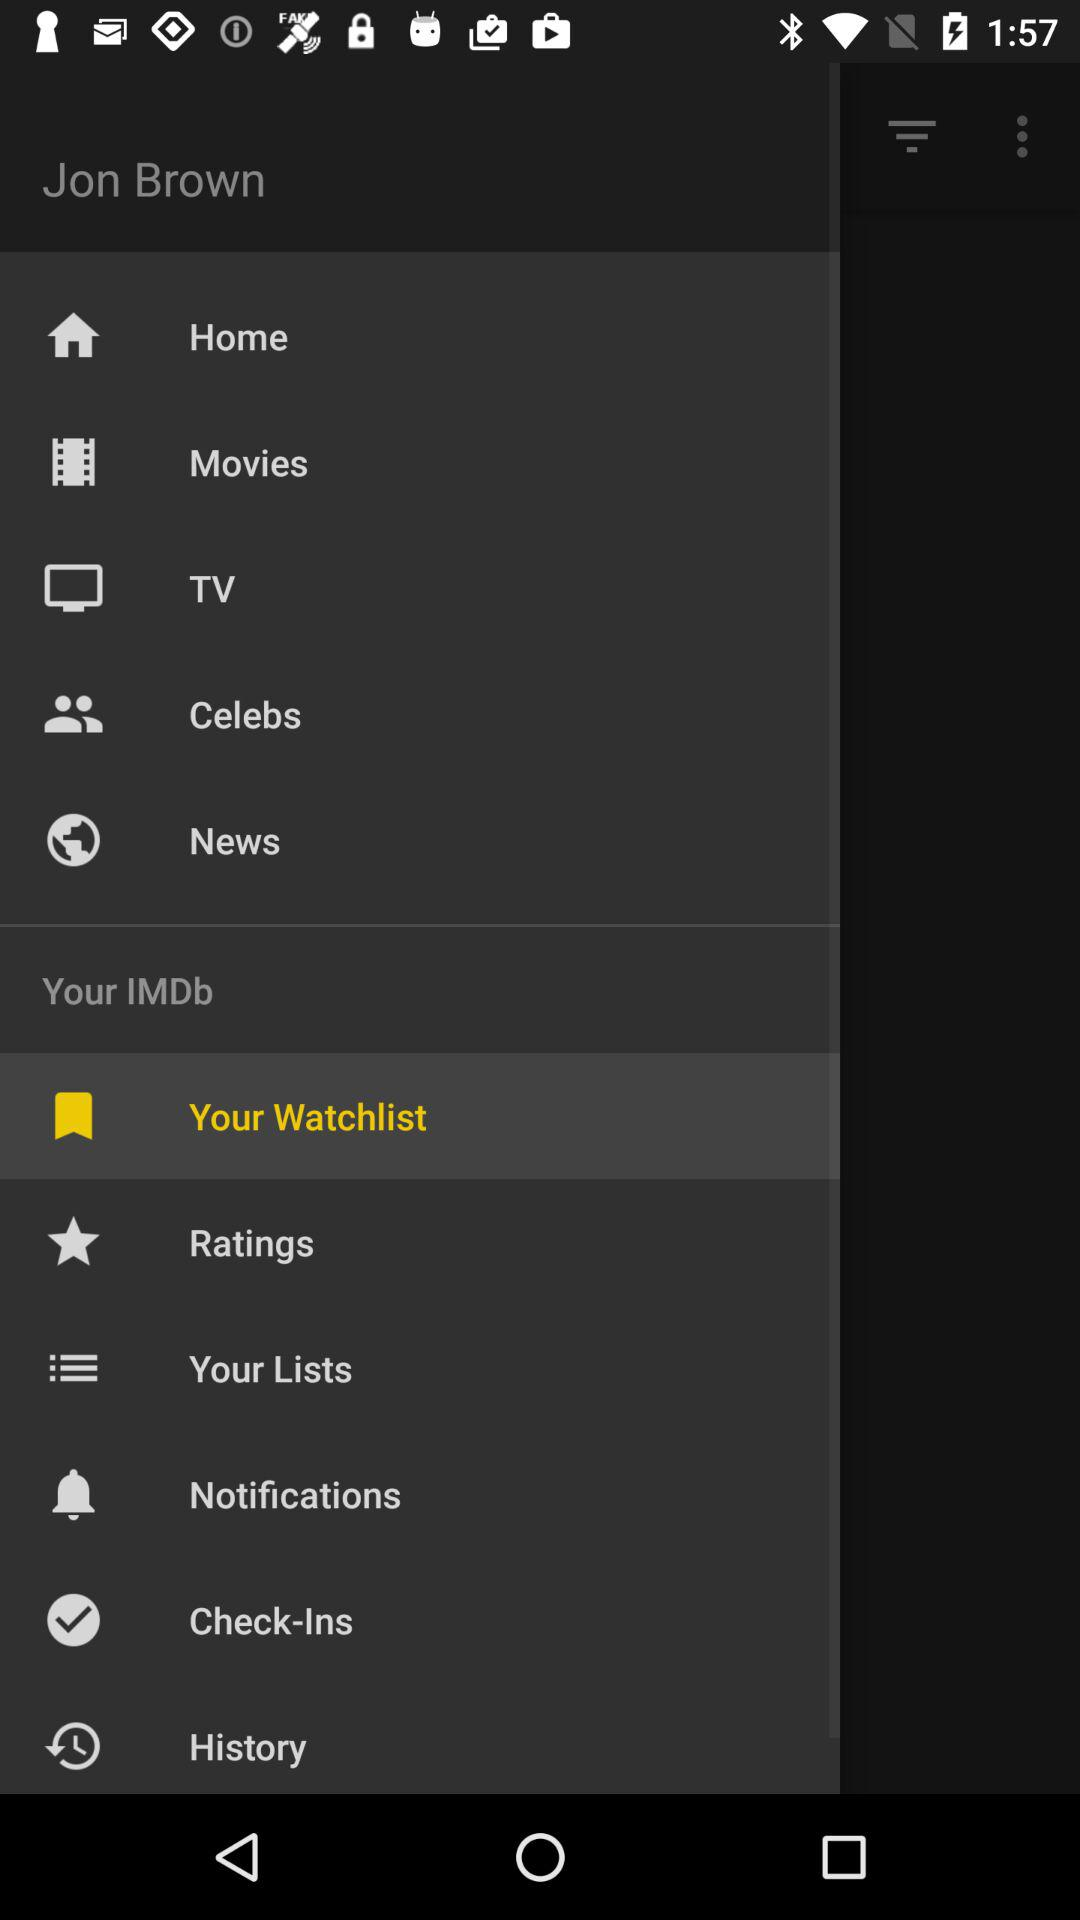What is the name of the user? The name of the user is Jon Brown. 